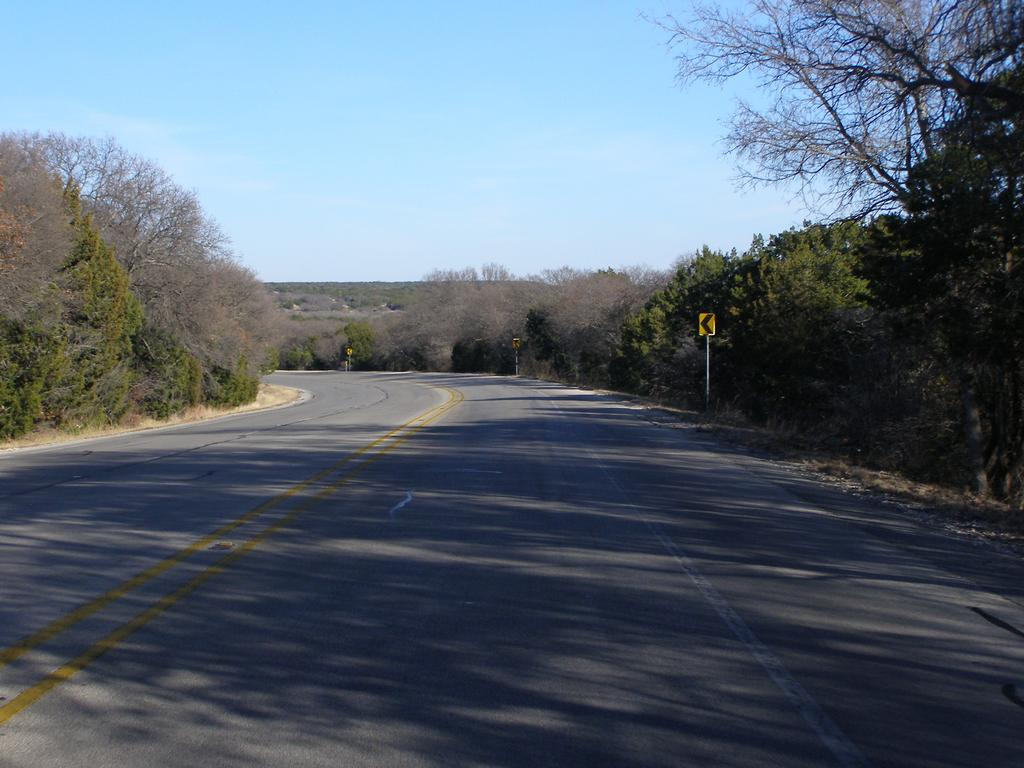What is the main feature in the center of the image? There is a path or way in the center of the image. What can be seen in the background of the image? There are trees and sign poles in the background of the image. Can you see the ocean in the background of the image? No, the ocean is not present in the image. The background features trees and sign poles. 